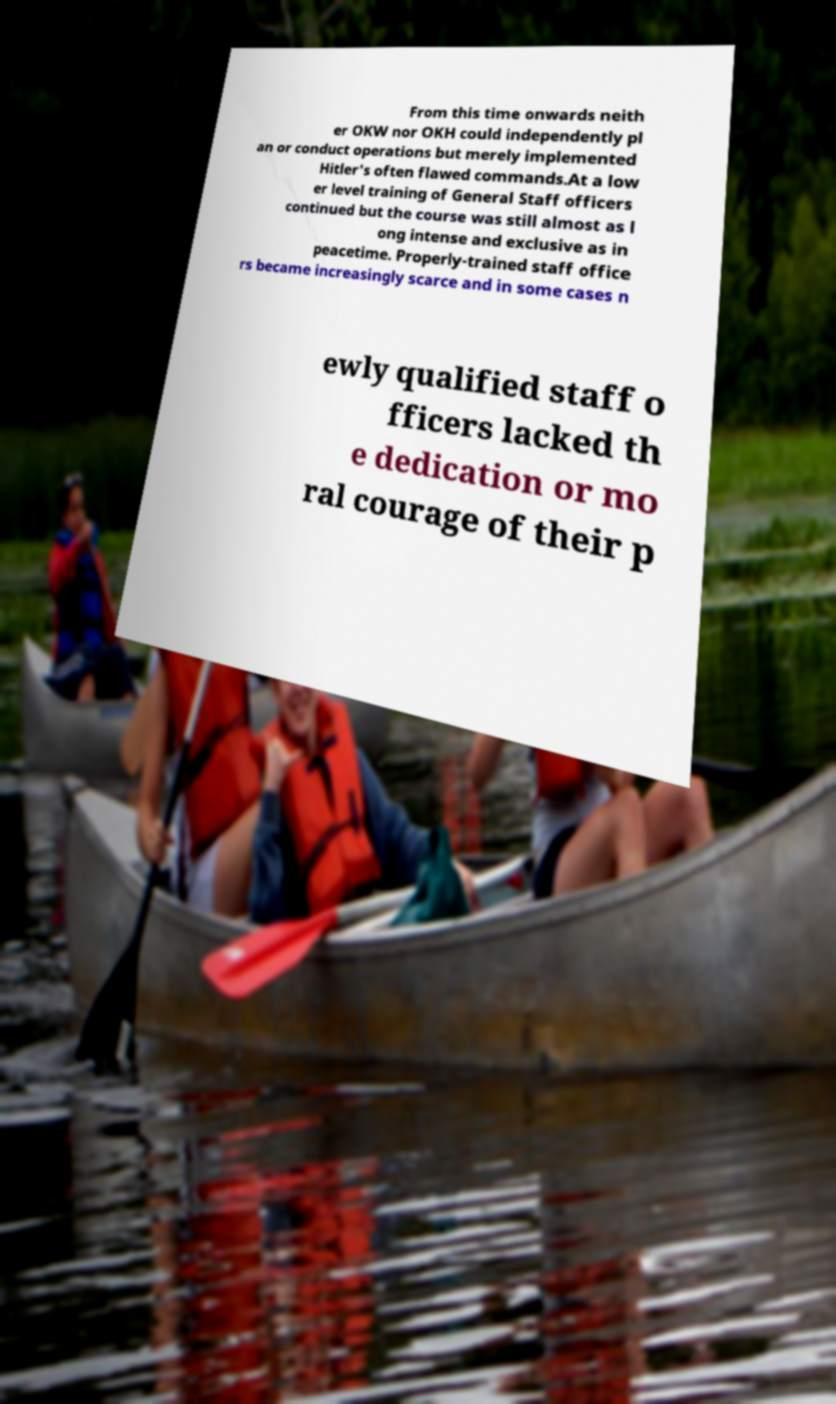I need the written content from this picture converted into text. Can you do that? From this time onwards neith er OKW nor OKH could independently pl an or conduct operations but merely implemented Hitler's often flawed commands.At a low er level training of General Staff officers continued but the course was still almost as l ong intense and exclusive as in peacetime. Properly-trained staff office rs became increasingly scarce and in some cases n ewly qualified staff o fficers lacked th e dedication or mo ral courage of their p 